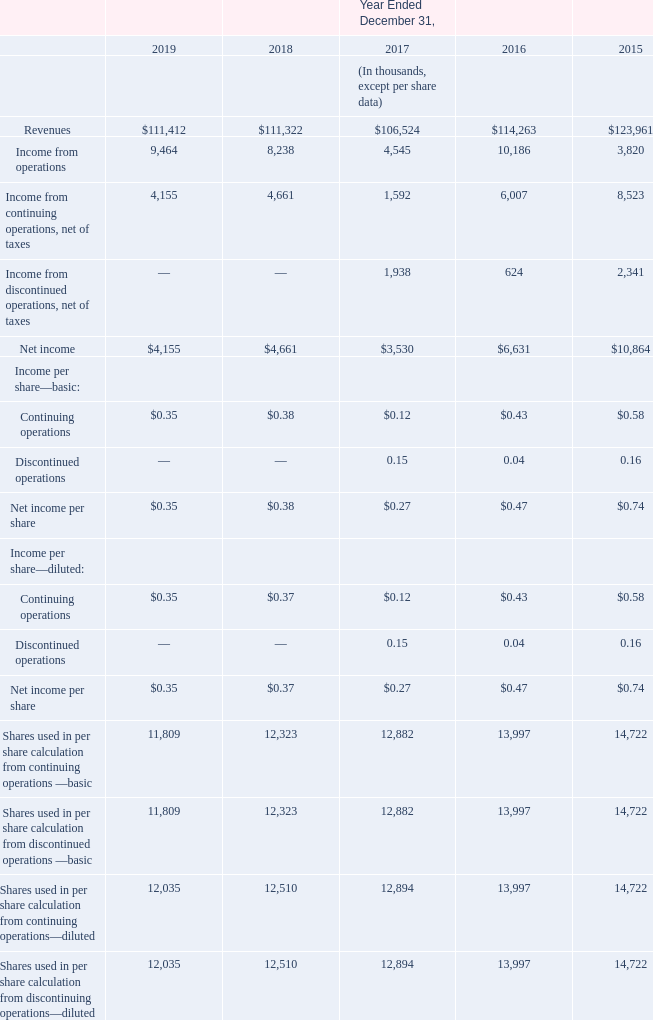Item 6. Selected Consolidated Financial Data
The following table presents selected consolidated financial data as of and for the five-year period ended December 31, 2019. Our past results of operations are not necessarily indicative of our future results of operations. The following selected consolidated financial data is qualified in its entirety by, and should be read in conjunction with, “Management's Discussion and Analysis of Financial Condition and Results of Operations” and the consolidated financial statements and the notes thereto included elsewhere herein.
Consolidated Statement of Operations Data:
What are the values of revenue for years ended December 31, 2019 to 2015 respectively?
Answer scale should be: thousand. $111,412, $111,322, $106,524, $114,263, $123,961. What are the values of income from operations for years ended December 31, 2019 to 2015 respectively?
Answer scale should be: thousand. 9,464, 8,238, 4,545, 10,186, 3,820. What does the table show? Selected consolidated financial data as of and for the five-year period ended december 31, 2019. What is the difference in revenue amount between 2019 and 2018?
Answer scale should be: thousand. 111,412 - 111,322 
Answer: 90. What is the average net income per share for basic shares from 2015 to 2019? (0.35+0.38+0.27+0.47+0.74)/5
Answer: 0.44. What is the percentage change of income from operations between 2018 to 2019?
Answer scale should be: percent. (9,464-8,238)/8,238
Answer: 14.88. 